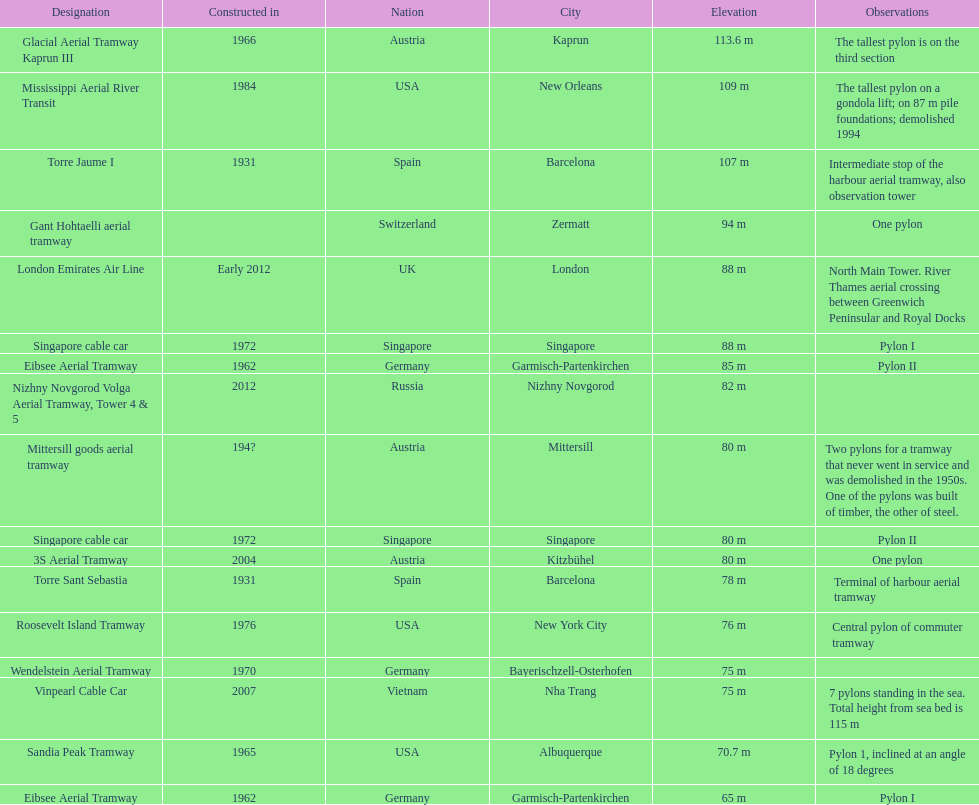The london emirates air line pylon has the same height as which pylon? Singapore cable car. 